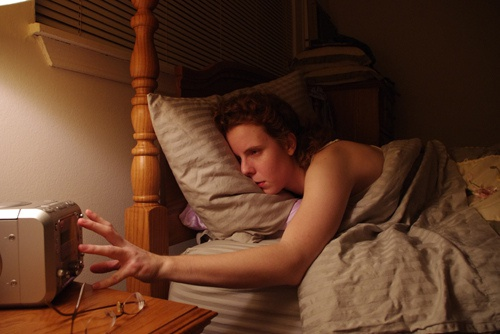Describe the objects in this image and their specific colors. I can see bed in ivory, black, gray, maroon, and brown tones, people in ivory, maroon, black, brown, and salmon tones, and clock in ivory, maroon, black, and brown tones in this image. 